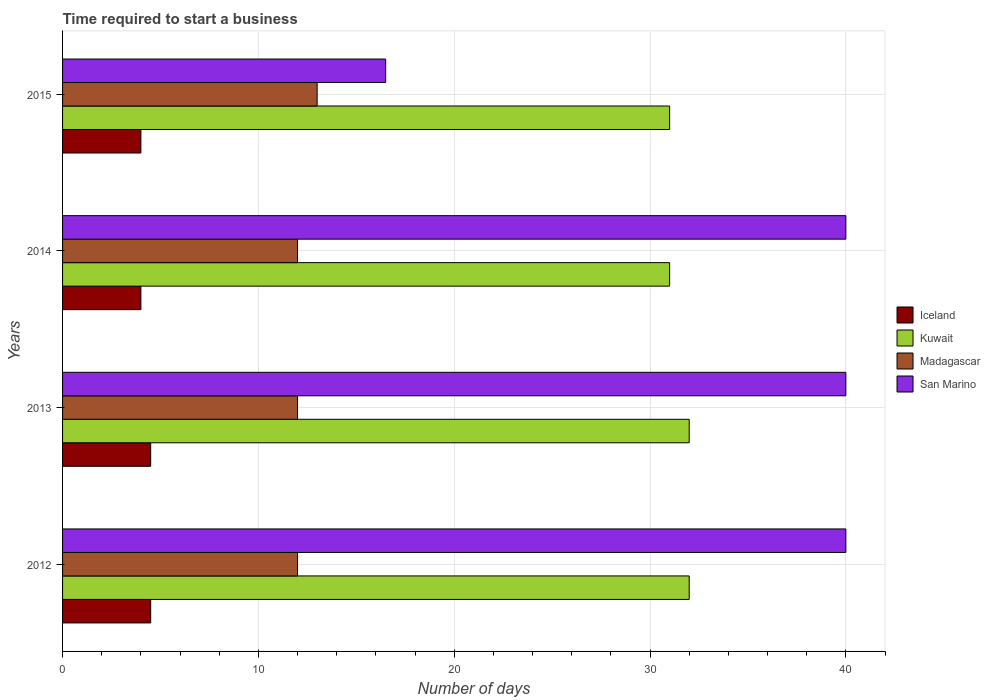How many different coloured bars are there?
Offer a terse response. 4. Are the number of bars per tick equal to the number of legend labels?
Offer a very short reply. Yes. How many bars are there on the 4th tick from the bottom?
Keep it short and to the point. 4. What is the label of the 3rd group of bars from the top?
Ensure brevity in your answer.  2013. In how many cases, is the number of bars for a given year not equal to the number of legend labels?
Offer a very short reply. 0. What is the number of days required to start a business in Madagascar in 2015?
Give a very brief answer. 13. In which year was the number of days required to start a business in San Marino maximum?
Make the answer very short. 2012. In which year was the number of days required to start a business in San Marino minimum?
Your answer should be compact. 2015. What is the total number of days required to start a business in Kuwait in the graph?
Give a very brief answer. 126. What is the average number of days required to start a business in Kuwait per year?
Ensure brevity in your answer.  31.5. What is the ratio of the number of days required to start a business in San Marino in 2014 to that in 2015?
Offer a very short reply. 2.42. Is the number of days required to start a business in Kuwait in 2014 less than that in 2015?
Your answer should be very brief. No. What is the difference between the highest and the second highest number of days required to start a business in Kuwait?
Your response must be concise. 0. Is the sum of the number of days required to start a business in Madagascar in 2012 and 2013 greater than the maximum number of days required to start a business in Iceland across all years?
Ensure brevity in your answer.  Yes. What does the 1st bar from the top in 2012 represents?
Keep it short and to the point. San Marino. What does the 2nd bar from the bottom in 2015 represents?
Keep it short and to the point. Kuwait. Is it the case that in every year, the sum of the number of days required to start a business in San Marino and number of days required to start a business in Madagascar is greater than the number of days required to start a business in Kuwait?
Offer a terse response. No. Are all the bars in the graph horizontal?
Make the answer very short. Yes. How many years are there in the graph?
Provide a succinct answer. 4. Are the values on the major ticks of X-axis written in scientific E-notation?
Make the answer very short. No. Where does the legend appear in the graph?
Your answer should be very brief. Center right. How many legend labels are there?
Your response must be concise. 4. How are the legend labels stacked?
Your answer should be compact. Vertical. What is the title of the graph?
Offer a very short reply. Time required to start a business. Does "Europe(developing only)" appear as one of the legend labels in the graph?
Provide a short and direct response. No. What is the label or title of the X-axis?
Ensure brevity in your answer.  Number of days. What is the label or title of the Y-axis?
Offer a very short reply. Years. What is the Number of days in Iceland in 2012?
Provide a succinct answer. 4.5. What is the Number of days in Kuwait in 2013?
Make the answer very short. 32. What is the Number of days in Madagascar in 2013?
Make the answer very short. 12. What is the Number of days of San Marino in 2013?
Ensure brevity in your answer.  40. What is the Number of days of Iceland in 2014?
Provide a short and direct response. 4. What is the Number of days of San Marino in 2014?
Make the answer very short. 40. What is the Number of days in Iceland in 2015?
Give a very brief answer. 4. What is the Number of days of Madagascar in 2015?
Offer a terse response. 13. Across all years, what is the maximum Number of days of Iceland?
Ensure brevity in your answer.  4.5. Across all years, what is the maximum Number of days in Kuwait?
Provide a short and direct response. 32. Across all years, what is the maximum Number of days of San Marino?
Your answer should be compact. 40. Across all years, what is the minimum Number of days of Iceland?
Provide a short and direct response. 4. Across all years, what is the minimum Number of days of Kuwait?
Your response must be concise. 31. Across all years, what is the minimum Number of days of Madagascar?
Your answer should be compact. 12. Across all years, what is the minimum Number of days of San Marino?
Your answer should be very brief. 16.5. What is the total Number of days in Iceland in the graph?
Offer a very short reply. 17. What is the total Number of days in Kuwait in the graph?
Provide a short and direct response. 126. What is the total Number of days in San Marino in the graph?
Make the answer very short. 136.5. What is the difference between the Number of days in Iceland in 2012 and that in 2013?
Provide a short and direct response. 0. What is the difference between the Number of days of Madagascar in 2012 and that in 2013?
Keep it short and to the point. 0. What is the difference between the Number of days of Iceland in 2012 and that in 2014?
Your answer should be very brief. 0.5. What is the difference between the Number of days in Kuwait in 2012 and that in 2014?
Give a very brief answer. 1. What is the difference between the Number of days of San Marino in 2012 and that in 2014?
Your answer should be compact. 0. What is the difference between the Number of days in Iceland in 2012 and that in 2015?
Give a very brief answer. 0.5. What is the difference between the Number of days in Madagascar in 2012 and that in 2015?
Your answer should be compact. -1. What is the difference between the Number of days of San Marino in 2012 and that in 2015?
Give a very brief answer. 23.5. What is the difference between the Number of days of Madagascar in 2013 and that in 2014?
Provide a short and direct response. 0. What is the difference between the Number of days of San Marino in 2013 and that in 2014?
Ensure brevity in your answer.  0. What is the difference between the Number of days in Iceland in 2013 and that in 2015?
Offer a terse response. 0.5. What is the difference between the Number of days in Kuwait in 2013 and that in 2015?
Give a very brief answer. 1. What is the difference between the Number of days of Madagascar in 2013 and that in 2015?
Provide a short and direct response. -1. What is the difference between the Number of days in Kuwait in 2014 and that in 2015?
Give a very brief answer. 0. What is the difference between the Number of days in Iceland in 2012 and the Number of days in Kuwait in 2013?
Your answer should be compact. -27.5. What is the difference between the Number of days in Iceland in 2012 and the Number of days in San Marino in 2013?
Ensure brevity in your answer.  -35.5. What is the difference between the Number of days of Kuwait in 2012 and the Number of days of San Marino in 2013?
Your response must be concise. -8. What is the difference between the Number of days in Madagascar in 2012 and the Number of days in San Marino in 2013?
Your answer should be compact. -28. What is the difference between the Number of days in Iceland in 2012 and the Number of days in Kuwait in 2014?
Provide a short and direct response. -26.5. What is the difference between the Number of days of Iceland in 2012 and the Number of days of San Marino in 2014?
Provide a short and direct response. -35.5. What is the difference between the Number of days in Kuwait in 2012 and the Number of days in Madagascar in 2014?
Ensure brevity in your answer.  20. What is the difference between the Number of days of Madagascar in 2012 and the Number of days of San Marino in 2014?
Keep it short and to the point. -28. What is the difference between the Number of days of Iceland in 2012 and the Number of days of Kuwait in 2015?
Provide a succinct answer. -26.5. What is the difference between the Number of days in Iceland in 2013 and the Number of days in Kuwait in 2014?
Make the answer very short. -26.5. What is the difference between the Number of days of Iceland in 2013 and the Number of days of Madagascar in 2014?
Your answer should be very brief. -7.5. What is the difference between the Number of days of Iceland in 2013 and the Number of days of San Marino in 2014?
Your answer should be very brief. -35.5. What is the difference between the Number of days of Kuwait in 2013 and the Number of days of San Marino in 2014?
Your response must be concise. -8. What is the difference between the Number of days in Iceland in 2013 and the Number of days in Kuwait in 2015?
Provide a succinct answer. -26.5. What is the difference between the Number of days of Iceland in 2013 and the Number of days of Madagascar in 2015?
Offer a very short reply. -8.5. What is the difference between the Number of days in Madagascar in 2013 and the Number of days in San Marino in 2015?
Your answer should be very brief. -4.5. What is the difference between the Number of days of Iceland in 2014 and the Number of days of Madagascar in 2015?
Ensure brevity in your answer.  -9. What is the average Number of days in Iceland per year?
Give a very brief answer. 4.25. What is the average Number of days of Kuwait per year?
Your response must be concise. 31.5. What is the average Number of days of Madagascar per year?
Offer a terse response. 12.25. What is the average Number of days of San Marino per year?
Give a very brief answer. 34.12. In the year 2012, what is the difference between the Number of days in Iceland and Number of days in Kuwait?
Give a very brief answer. -27.5. In the year 2012, what is the difference between the Number of days of Iceland and Number of days of San Marino?
Make the answer very short. -35.5. In the year 2012, what is the difference between the Number of days in Kuwait and Number of days in Madagascar?
Ensure brevity in your answer.  20. In the year 2012, what is the difference between the Number of days in Kuwait and Number of days in San Marino?
Your response must be concise. -8. In the year 2013, what is the difference between the Number of days of Iceland and Number of days of Kuwait?
Make the answer very short. -27.5. In the year 2013, what is the difference between the Number of days of Iceland and Number of days of Madagascar?
Ensure brevity in your answer.  -7.5. In the year 2013, what is the difference between the Number of days in Iceland and Number of days in San Marino?
Provide a succinct answer. -35.5. In the year 2013, what is the difference between the Number of days in Kuwait and Number of days in Madagascar?
Keep it short and to the point. 20. In the year 2014, what is the difference between the Number of days in Iceland and Number of days in Kuwait?
Offer a terse response. -27. In the year 2014, what is the difference between the Number of days of Iceland and Number of days of San Marino?
Your response must be concise. -36. In the year 2014, what is the difference between the Number of days in Kuwait and Number of days in San Marino?
Offer a terse response. -9. In the year 2015, what is the difference between the Number of days of Kuwait and Number of days of San Marino?
Ensure brevity in your answer.  14.5. What is the ratio of the Number of days of Iceland in 2012 to that in 2014?
Keep it short and to the point. 1.12. What is the ratio of the Number of days in Kuwait in 2012 to that in 2014?
Provide a succinct answer. 1.03. What is the ratio of the Number of days in Madagascar in 2012 to that in 2014?
Offer a very short reply. 1. What is the ratio of the Number of days of San Marino in 2012 to that in 2014?
Make the answer very short. 1. What is the ratio of the Number of days of Kuwait in 2012 to that in 2015?
Offer a very short reply. 1.03. What is the ratio of the Number of days of Madagascar in 2012 to that in 2015?
Provide a succinct answer. 0.92. What is the ratio of the Number of days in San Marino in 2012 to that in 2015?
Offer a very short reply. 2.42. What is the ratio of the Number of days of Iceland in 2013 to that in 2014?
Provide a short and direct response. 1.12. What is the ratio of the Number of days in Kuwait in 2013 to that in 2014?
Make the answer very short. 1.03. What is the ratio of the Number of days of Kuwait in 2013 to that in 2015?
Offer a terse response. 1.03. What is the ratio of the Number of days of San Marino in 2013 to that in 2015?
Provide a short and direct response. 2.42. What is the ratio of the Number of days of Iceland in 2014 to that in 2015?
Provide a succinct answer. 1. What is the ratio of the Number of days in Madagascar in 2014 to that in 2015?
Offer a terse response. 0.92. What is the ratio of the Number of days of San Marino in 2014 to that in 2015?
Your response must be concise. 2.42. What is the difference between the highest and the second highest Number of days in Iceland?
Your response must be concise. 0. What is the difference between the highest and the second highest Number of days in San Marino?
Make the answer very short. 0. What is the difference between the highest and the lowest Number of days of Iceland?
Provide a succinct answer. 0.5. 